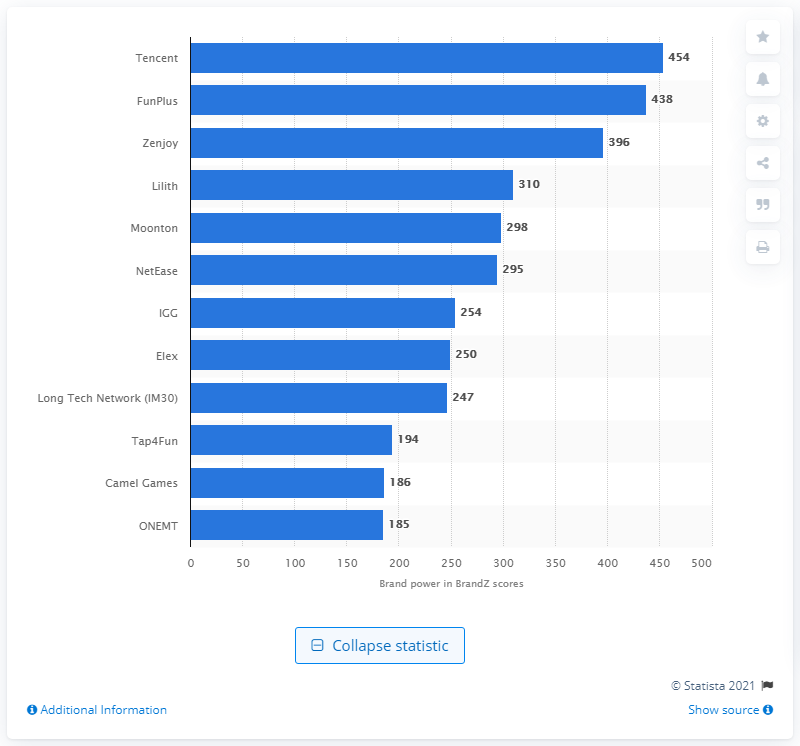Mention a couple of crucial points in this snapshot. FunPlus Technology Company, Ltd. received 438 brand power scores during the survey period. 